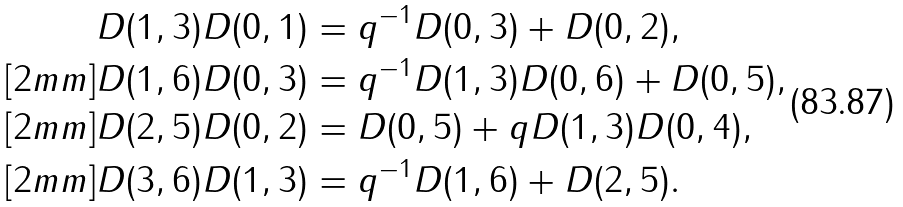Convert formula to latex. <formula><loc_0><loc_0><loc_500><loc_500>D ( 1 , 3 ) D ( 0 , 1 ) & = q ^ { - 1 } D ( 0 , 3 ) + D ( 0 , 2 ) , \\ [ 2 m m ] D ( 1 , 6 ) D ( 0 , 3 ) & = q ^ { - 1 } D ( 1 , 3 ) D ( 0 , 6 ) + D ( 0 , 5 ) , \\ [ 2 m m ] D ( 2 , 5 ) D ( 0 , 2 ) & = D ( 0 , 5 ) + q D ( 1 , 3 ) D ( 0 , 4 ) , \\ [ 2 m m ] D ( 3 , 6 ) D ( 1 , 3 ) & = q ^ { - 1 } D ( 1 , 6 ) + D ( 2 , 5 ) .</formula> 